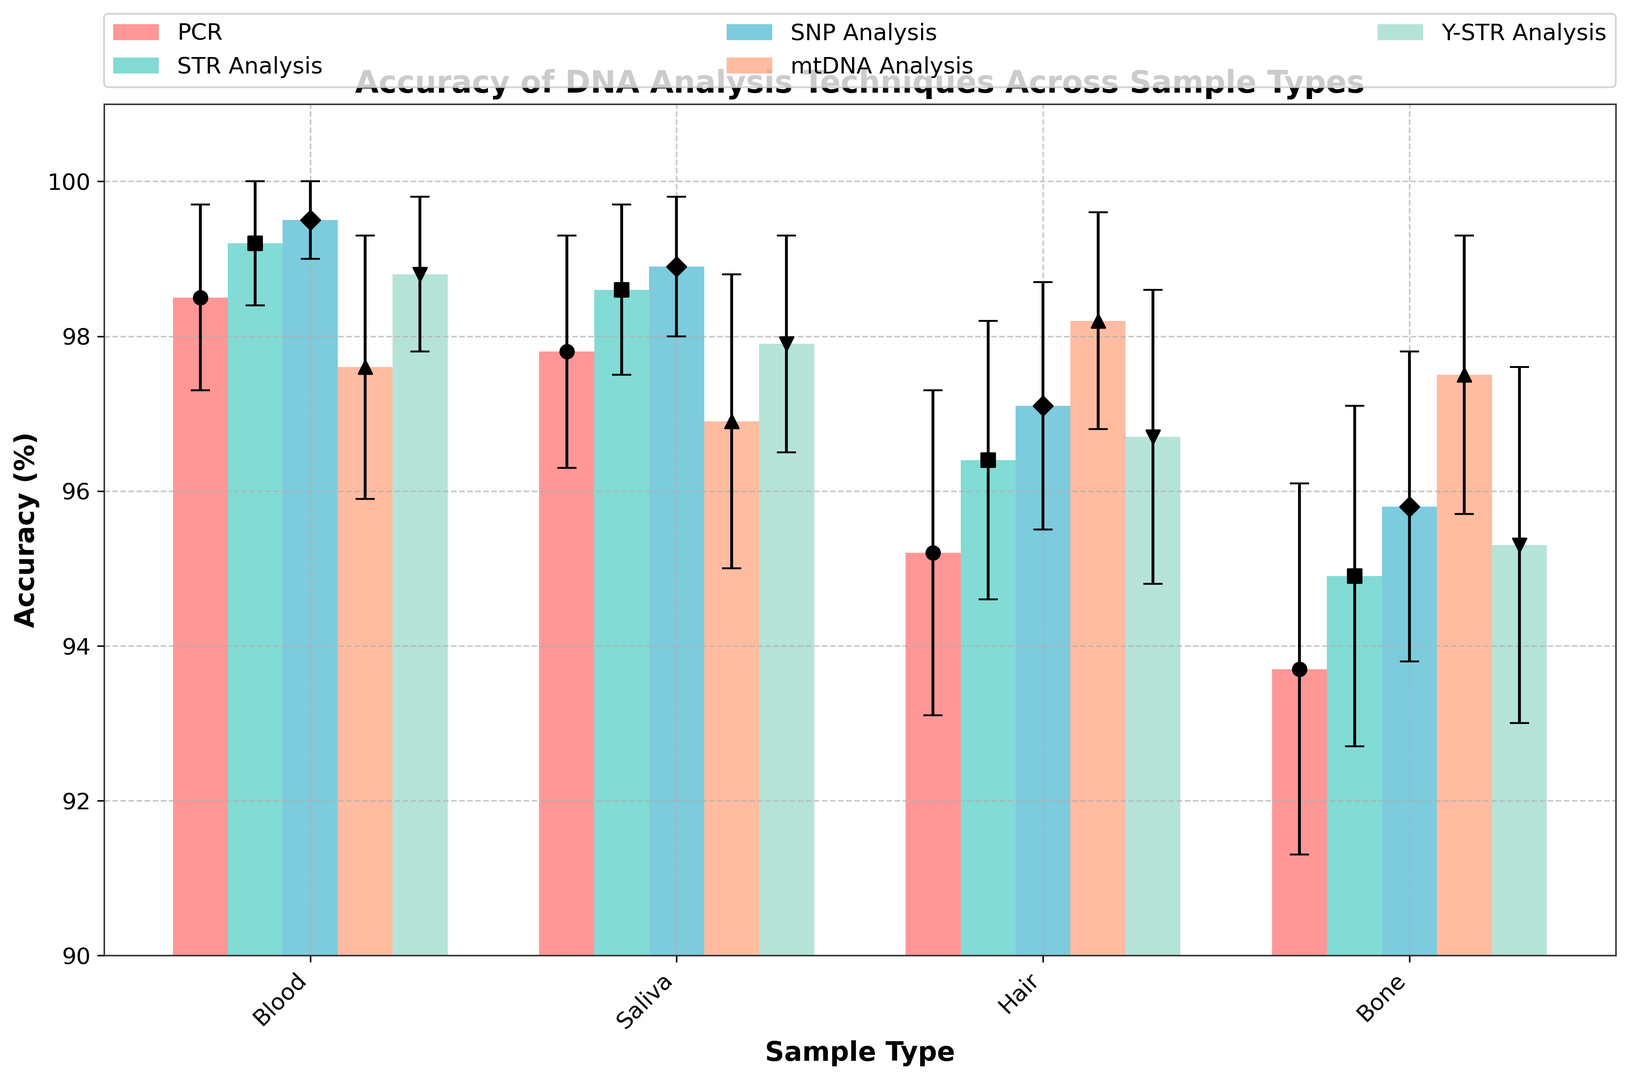Which DNA analysis technique has the highest average accuracy across all sample types? To find the highest average accuracy, we calculate the average accuracy for each DNA analysis technique across the Blood, Saliva, Hair, and Bone samples. PCR: (98.5+97.8+95.2+93.7)/4 = 96.3, STR Analysis: (99.2+98.6+96.4+94.9)/4 = 97.775, SNP Analysis: (99.5+98.9+97.1+95.8)/4 = 97.825, mtDNA Analysis: (97.6+96.9+98.2+97.5)/4 = 97.55, Y-STR Analysis: (98.8+97.9+96.7+95.3)/4 = 97.175. SNP Analysis has the highest average accuracy.
Answer: SNP Analysis Which sample type has the lowest accuracy for all techniques? Check the accuracy values for each sample type across all techniques. Blood: 98.5, 99.2, 99.5, 97.6, 98.8; Saliva: 97.8, 98.6, 98.9, 96.9, 97.9; Hair: 95.2, 96.4, 97.1, 98.2, 96.7; Bone: 93.7, 94.9, 95.8, 97.5, 95.3. Bone has the lowest maximum accuracy of 97.5 for mtDNA Analysis.
Answer: Bone What is the difference in accuracy between SNP Analysis and STR Analysis for Saliva samples? Look at the chart to get the accuracy percentages for SNP Analysis and STR Analysis for Saliva samples. SNP Analysis accuracy for Saliva is 98.9%, and STR Analysis accuracy for Saliva is 98.6%. The difference is calculated as 98.9 - 98.6 = 0.3%.
Answer: 0.3% Which technique has the smallest error margin across all sample types? Check the error margins for each technique. PCR: 1.2, 1.5, 2.1, 2.4; STR Analysis: 0.8, 1.1, 1.8, 2.2; SNP Analysis: 0.5, 0.9, 1.6, 2.0; mtDNA Analysis: 1.7, 1.9, 1.4, 1.8; Y-STR Analysis: 1.0, 1.4, 1.9, 2.3. SNP Analysis has the smallest maximum error margin of 2.0.
Answer: SNP Analysis For which technique and sample type combination is the accuracy closest to 98%? Look for accuracy values closest to 98%. PCR: Blood (98.5), STR Analysis: Blood (99.2), SNP Analysis: Blood (99.5), mtDNA Analysis: Hair (98.2), Y-STR Analysis: Blood (98.8). mtDNA Analysis of Hair at 98.2% is closest to 98.
Answer: mtDNA Analysis, Hair How does the accuracy of mtDNA Analysis compare between Blood and Saliva samples? Compare the accuracy values for mtDNA Analysis between Blood and Saliva samples. Blood: 97.6%, Saliva: 96.9%. 97.6% is greater than 96.9% by 0.7%.
Answer: Blood is higher by 0.7% Which sample type has the highest range of accuracy values across all techniques? Calculate the range (max - min) of accuracies for each sample type. Blood: max 99.5 - min 97.6 = 1.9, Saliva: max 98.9 - min 96.9 = 2.0, Hair: max 98.2 - min 95.2 = 3.0, Bone: max 97.5 - min 93.7 = 3.8. Bone has the highest range of 3.8.
Answer: Bone What is the total average accuracy of all techniques across Hair samples? Calculate the average for each technique and then find the average of those averages. PCR: 95.2, STR Analysis: 96.4, SNP Analysis: 97.1, mtDNA Analysis: 98.2, Y-STR Analysis: 96.7. (95.2 + 96.4 + 97.1 + 98.2 + 96.7) / 5 = 96.72%.
Answer: 96.72% What is the ratio of accuracy between PCR and Y-STR Analysis for the Bone sample? Check the accuracy values for PCR and Y-STR Analysis for the Bone sample. PCR: 93.7%, Y-STR Analysis: 95.3%. The ratio is 93.7 / 95.3 ≈ 0.983.
Answer: 0.983 